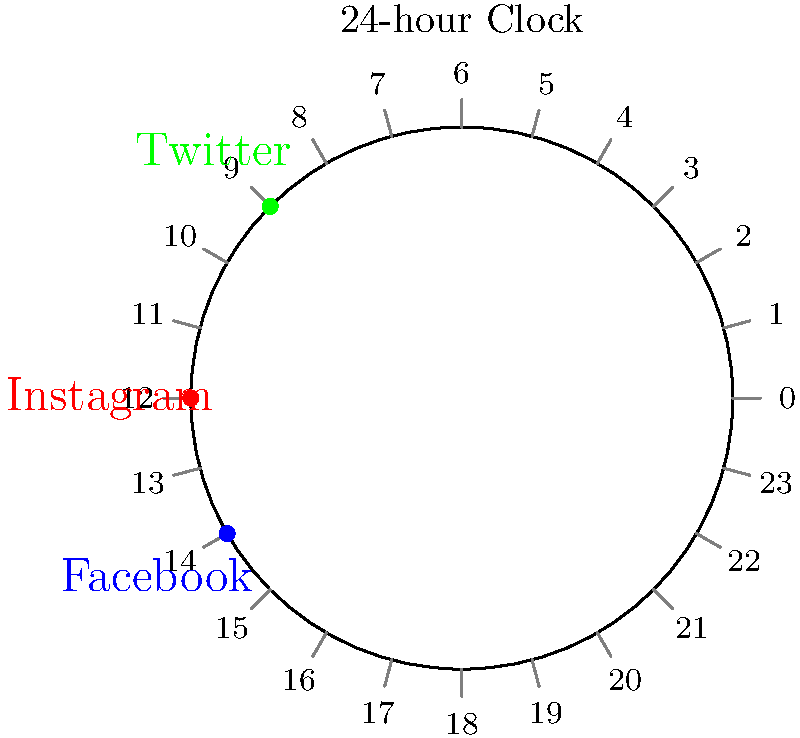Based on the 24-hour clock diagram showing optimal posting times for different social media platforms, what is the total number of hours between the best posting times for Facebook and Twitter? To solve this problem, we need to follow these steps:

1. Identify the best posting times for Facebook and Twitter from the diagram:
   - Facebook: 14:00 (2 PM)
   - Twitter: 9:00 (9 AM)

2. Calculate the time difference:
   $14:00 - 9:00 = 5$ hours

3. Consider that the question asks for the total number of hours between the two times. In a 24-hour clock, there are two ways to measure this:
   a) Clockwise: 5 hours (from 9:00 to 14:00)
   b) Counterclockwise: 19 hours (from 14:00 to 9:00 the next day)

4. The total number of hours between the two times is the smaller of these two values, which is 5 hours.

Therefore, the total number of hours between the best posting times for Facebook and Twitter is 5 hours.
Answer: 5 hours 